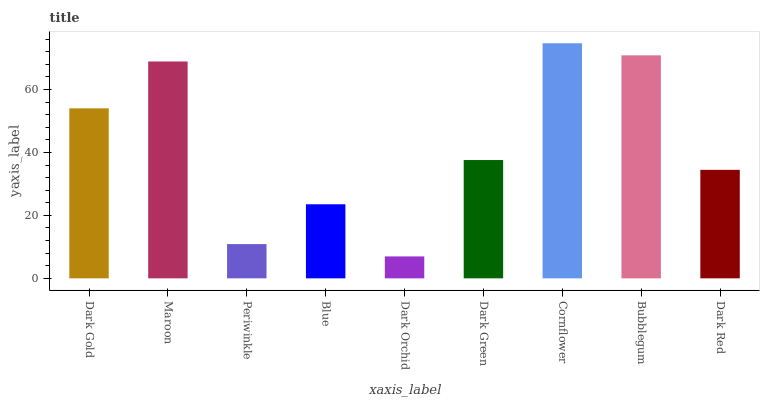Is Dark Orchid the minimum?
Answer yes or no. Yes. Is Cornflower the maximum?
Answer yes or no. Yes. Is Maroon the minimum?
Answer yes or no. No. Is Maroon the maximum?
Answer yes or no. No. Is Maroon greater than Dark Gold?
Answer yes or no. Yes. Is Dark Gold less than Maroon?
Answer yes or no. Yes. Is Dark Gold greater than Maroon?
Answer yes or no. No. Is Maroon less than Dark Gold?
Answer yes or no. No. Is Dark Green the high median?
Answer yes or no. Yes. Is Dark Green the low median?
Answer yes or no. Yes. Is Dark Orchid the high median?
Answer yes or no. No. Is Periwinkle the low median?
Answer yes or no. No. 